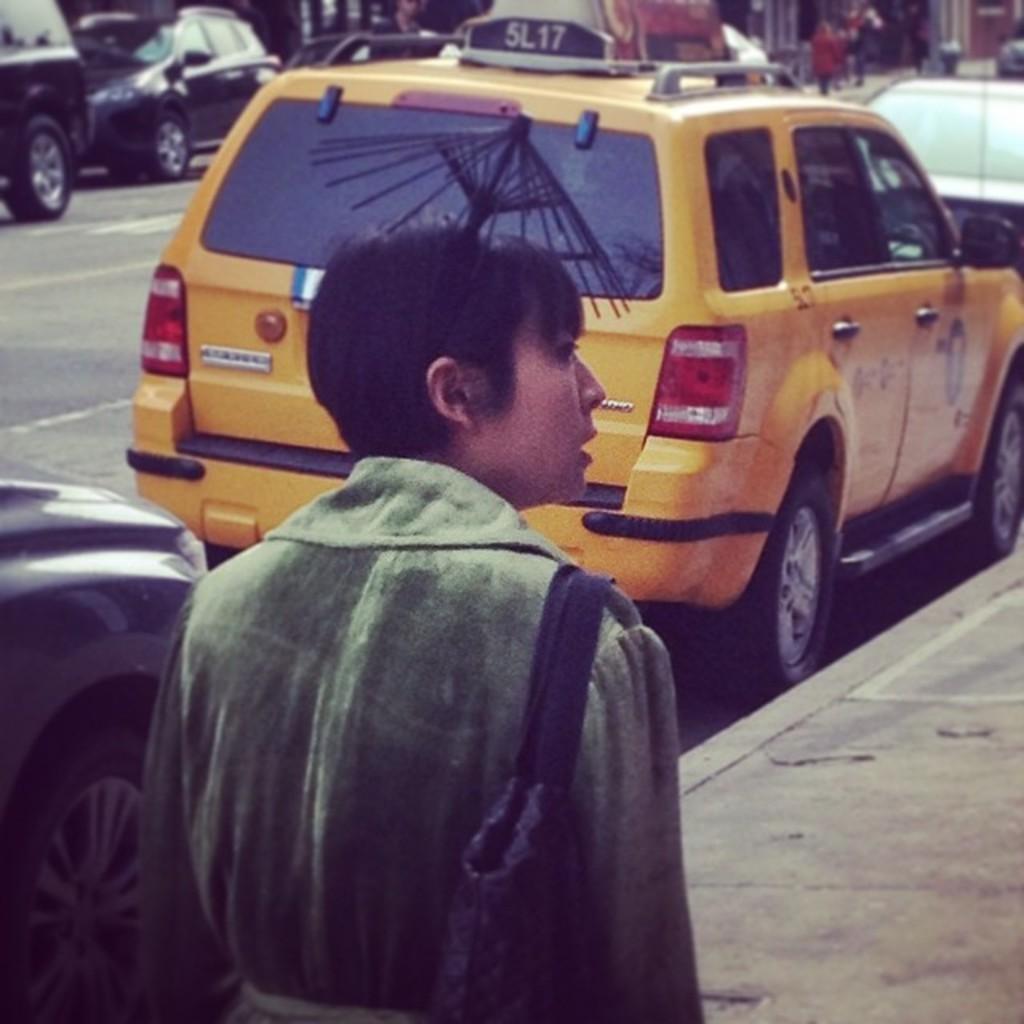What is written on the sign on the roof of the car?
Provide a succinct answer. 5l17. 